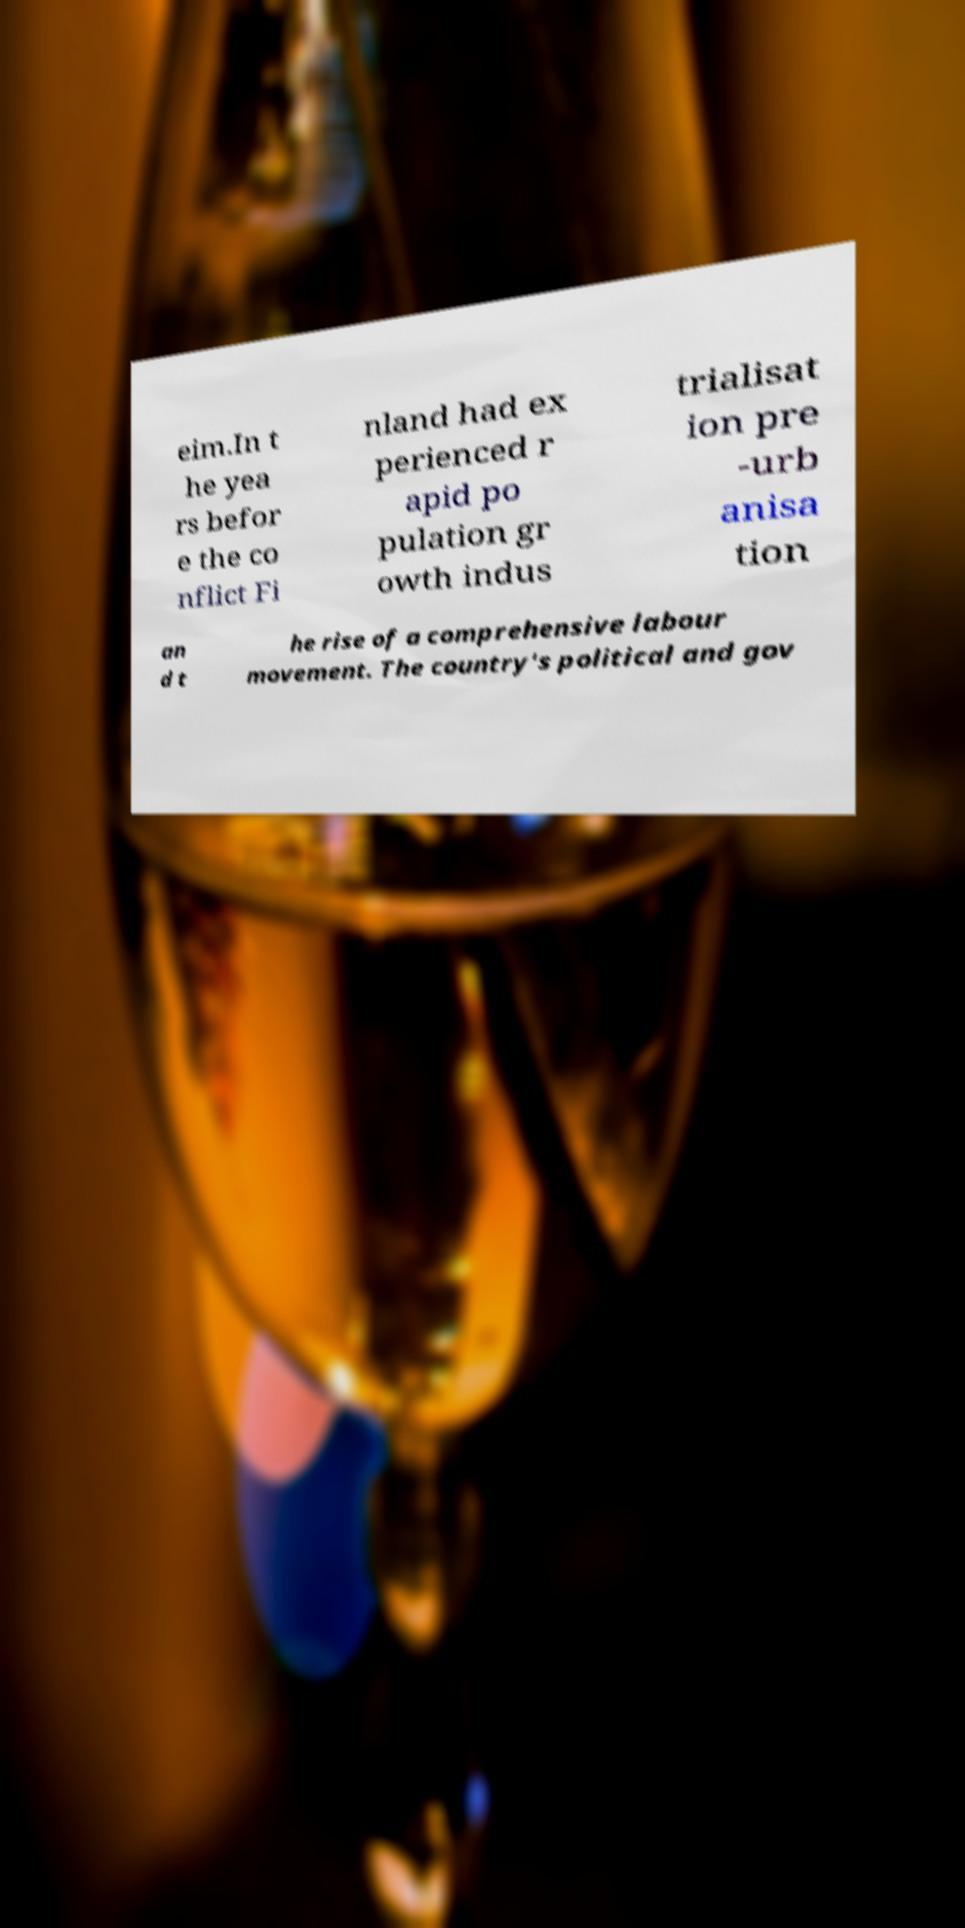Can you accurately transcribe the text from the provided image for me? eim.In t he yea rs befor e the co nflict Fi nland had ex perienced r apid po pulation gr owth indus trialisat ion pre -urb anisa tion an d t he rise of a comprehensive labour movement. The country's political and gov 